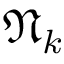Convert formula to latex. <formula><loc_0><loc_0><loc_500><loc_500>\mathfrak { N } _ { k }</formula> 